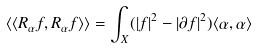<formula> <loc_0><loc_0><loc_500><loc_500>\langle \langle R _ { \alpha } f , R _ { \alpha } f \rangle \rangle = \int _ { X } ( | f | ^ { 2 } - | \partial f | ^ { 2 } ) \langle \alpha , \alpha \rangle</formula> 